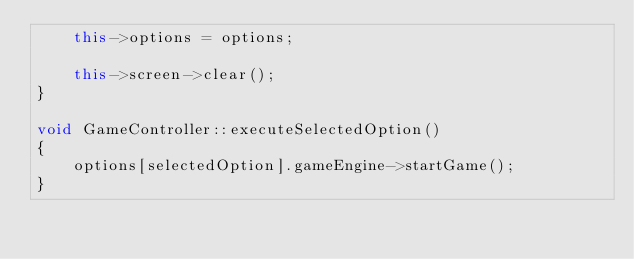<code> <loc_0><loc_0><loc_500><loc_500><_C++_>    this->options = options;

    this->screen->clear();
}

void GameController::executeSelectedOption()
{
    options[selectedOption].gameEngine->startGame();
}
</code> 